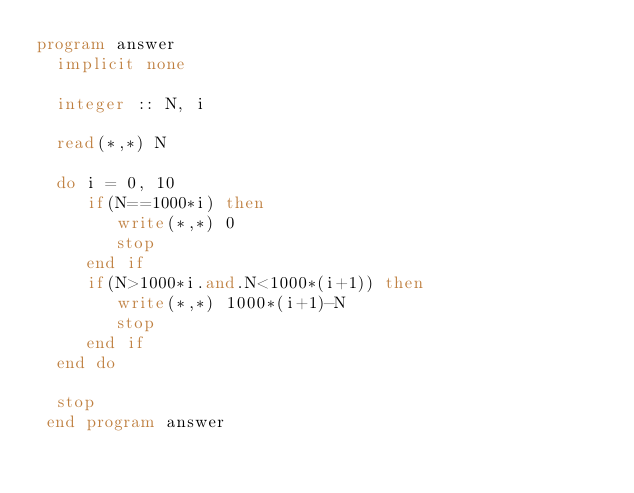<code> <loc_0><loc_0><loc_500><loc_500><_FORTRAN_>program answer
  implicit none

  integer :: N, i

  read(*,*) N

  do i = 0, 10
     if(N==1000*i) then
        write(*,*) 0
        stop
     end if
     if(N>1000*i.and.N<1000*(i+1)) then
        write(*,*) 1000*(i+1)-N
        stop
     end if
  end do

  stop
 end program answer</code> 